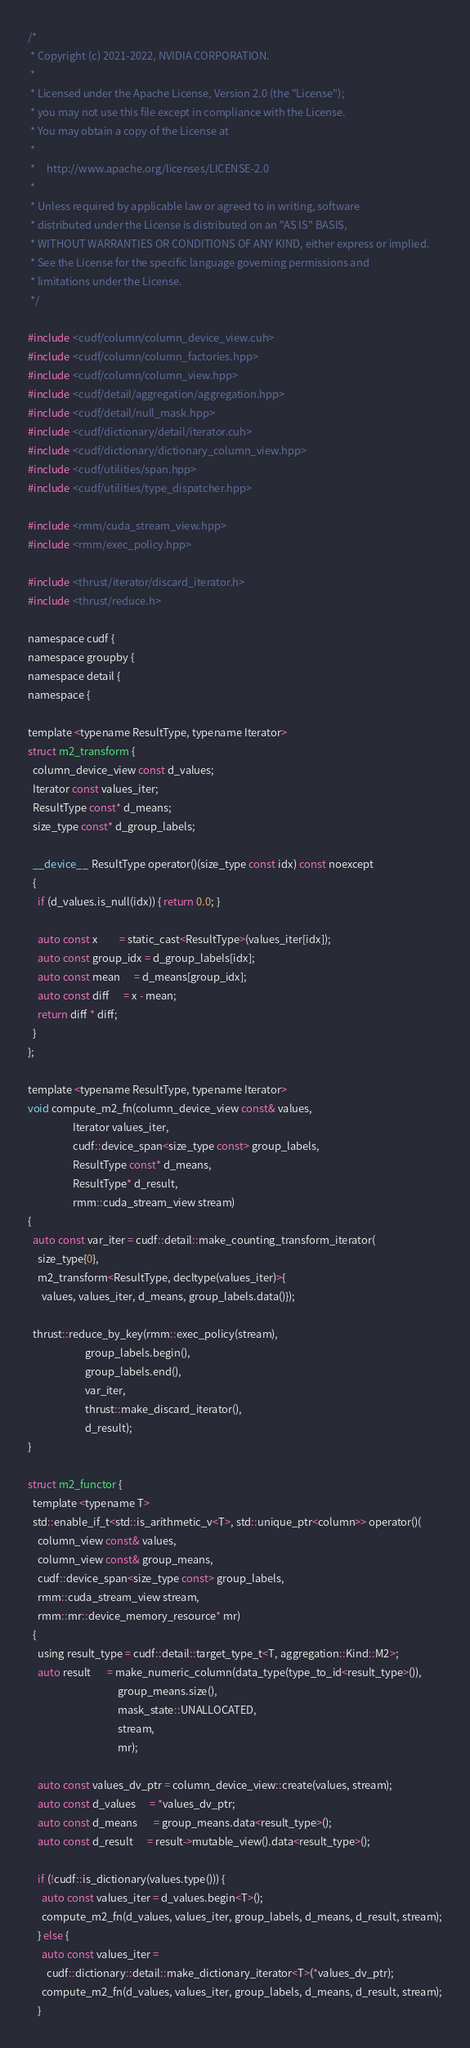<code> <loc_0><loc_0><loc_500><loc_500><_Cuda_>/*
 * Copyright (c) 2021-2022, NVIDIA CORPORATION.
 *
 * Licensed under the Apache License, Version 2.0 (the "License");
 * you may not use this file except in compliance with the License.
 * You may obtain a copy of the License at
 *
 *     http://www.apache.org/licenses/LICENSE-2.0
 *
 * Unless required by applicable law or agreed to in writing, software
 * distributed under the License is distributed on an "AS IS" BASIS,
 * WITHOUT WARRANTIES OR CONDITIONS OF ANY KIND, either express or implied.
 * See the License for the specific language governing permissions and
 * limitations under the License.
 */

#include <cudf/column/column_device_view.cuh>
#include <cudf/column/column_factories.hpp>
#include <cudf/column/column_view.hpp>
#include <cudf/detail/aggregation/aggregation.hpp>
#include <cudf/detail/null_mask.hpp>
#include <cudf/dictionary/detail/iterator.cuh>
#include <cudf/dictionary/dictionary_column_view.hpp>
#include <cudf/utilities/span.hpp>
#include <cudf/utilities/type_dispatcher.hpp>

#include <rmm/cuda_stream_view.hpp>
#include <rmm/exec_policy.hpp>

#include <thrust/iterator/discard_iterator.h>
#include <thrust/reduce.h>

namespace cudf {
namespace groupby {
namespace detail {
namespace {

template <typename ResultType, typename Iterator>
struct m2_transform {
  column_device_view const d_values;
  Iterator const values_iter;
  ResultType const* d_means;
  size_type const* d_group_labels;

  __device__ ResultType operator()(size_type const idx) const noexcept
  {
    if (d_values.is_null(idx)) { return 0.0; }

    auto const x         = static_cast<ResultType>(values_iter[idx]);
    auto const group_idx = d_group_labels[idx];
    auto const mean      = d_means[group_idx];
    auto const diff      = x - mean;
    return diff * diff;
  }
};

template <typename ResultType, typename Iterator>
void compute_m2_fn(column_device_view const& values,
                   Iterator values_iter,
                   cudf::device_span<size_type const> group_labels,
                   ResultType const* d_means,
                   ResultType* d_result,
                   rmm::cuda_stream_view stream)
{
  auto const var_iter = cudf::detail::make_counting_transform_iterator(
    size_type{0},
    m2_transform<ResultType, decltype(values_iter)>{
      values, values_iter, d_means, group_labels.data()});

  thrust::reduce_by_key(rmm::exec_policy(stream),
                        group_labels.begin(),
                        group_labels.end(),
                        var_iter,
                        thrust::make_discard_iterator(),
                        d_result);
}

struct m2_functor {
  template <typename T>
  std::enable_if_t<std::is_arithmetic_v<T>, std::unique_ptr<column>> operator()(
    column_view const& values,
    column_view const& group_means,
    cudf::device_span<size_type const> group_labels,
    rmm::cuda_stream_view stream,
    rmm::mr::device_memory_resource* mr)
  {
    using result_type = cudf::detail::target_type_t<T, aggregation::Kind::M2>;
    auto result       = make_numeric_column(data_type(type_to_id<result_type>()),
                                      group_means.size(),
                                      mask_state::UNALLOCATED,
                                      stream,
                                      mr);

    auto const values_dv_ptr = column_device_view::create(values, stream);
    auto const d_values      = *values_dv_ptr;
    auto const d_means       = group_means.data<result_type>();
    auto const d_result      = result->mutable_view().data<result_type>();

    if (!cudf::is_dictionary(values.type())) {
      auto const values_iter = d_values.begin<T>();
      compute_m2_fn(d_values, values_iter, group_labels, d_means, d_result, stream);
    } else {
      auto const values_iter =
        cudf::dictionary::detail::make_dictionary_iterator<T>(*values_dv_ptr);
      compute_m2_fn(d_values, values_iter, group_labels, d_means, d_result, stream);
    }
</code> 